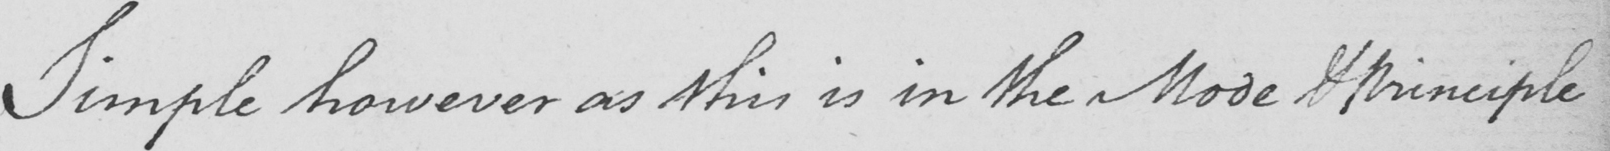What does this handwritten line say? Simple however as this is in the Mode & Principle 